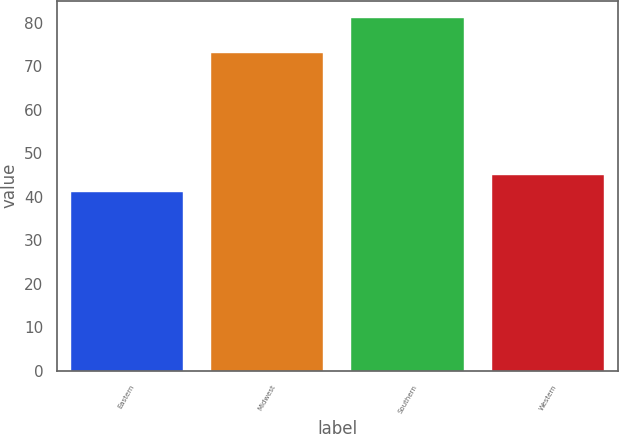Convert chart. <chart><loc_0><loc_0><loc_500><loc_500><bar_chart><fcel>Eastern<fcel>Midwest<fcel>Southern<fcel>Western<nl><fcel>41<fcel>73<fcel>81<fcel>45<nl></chart> 